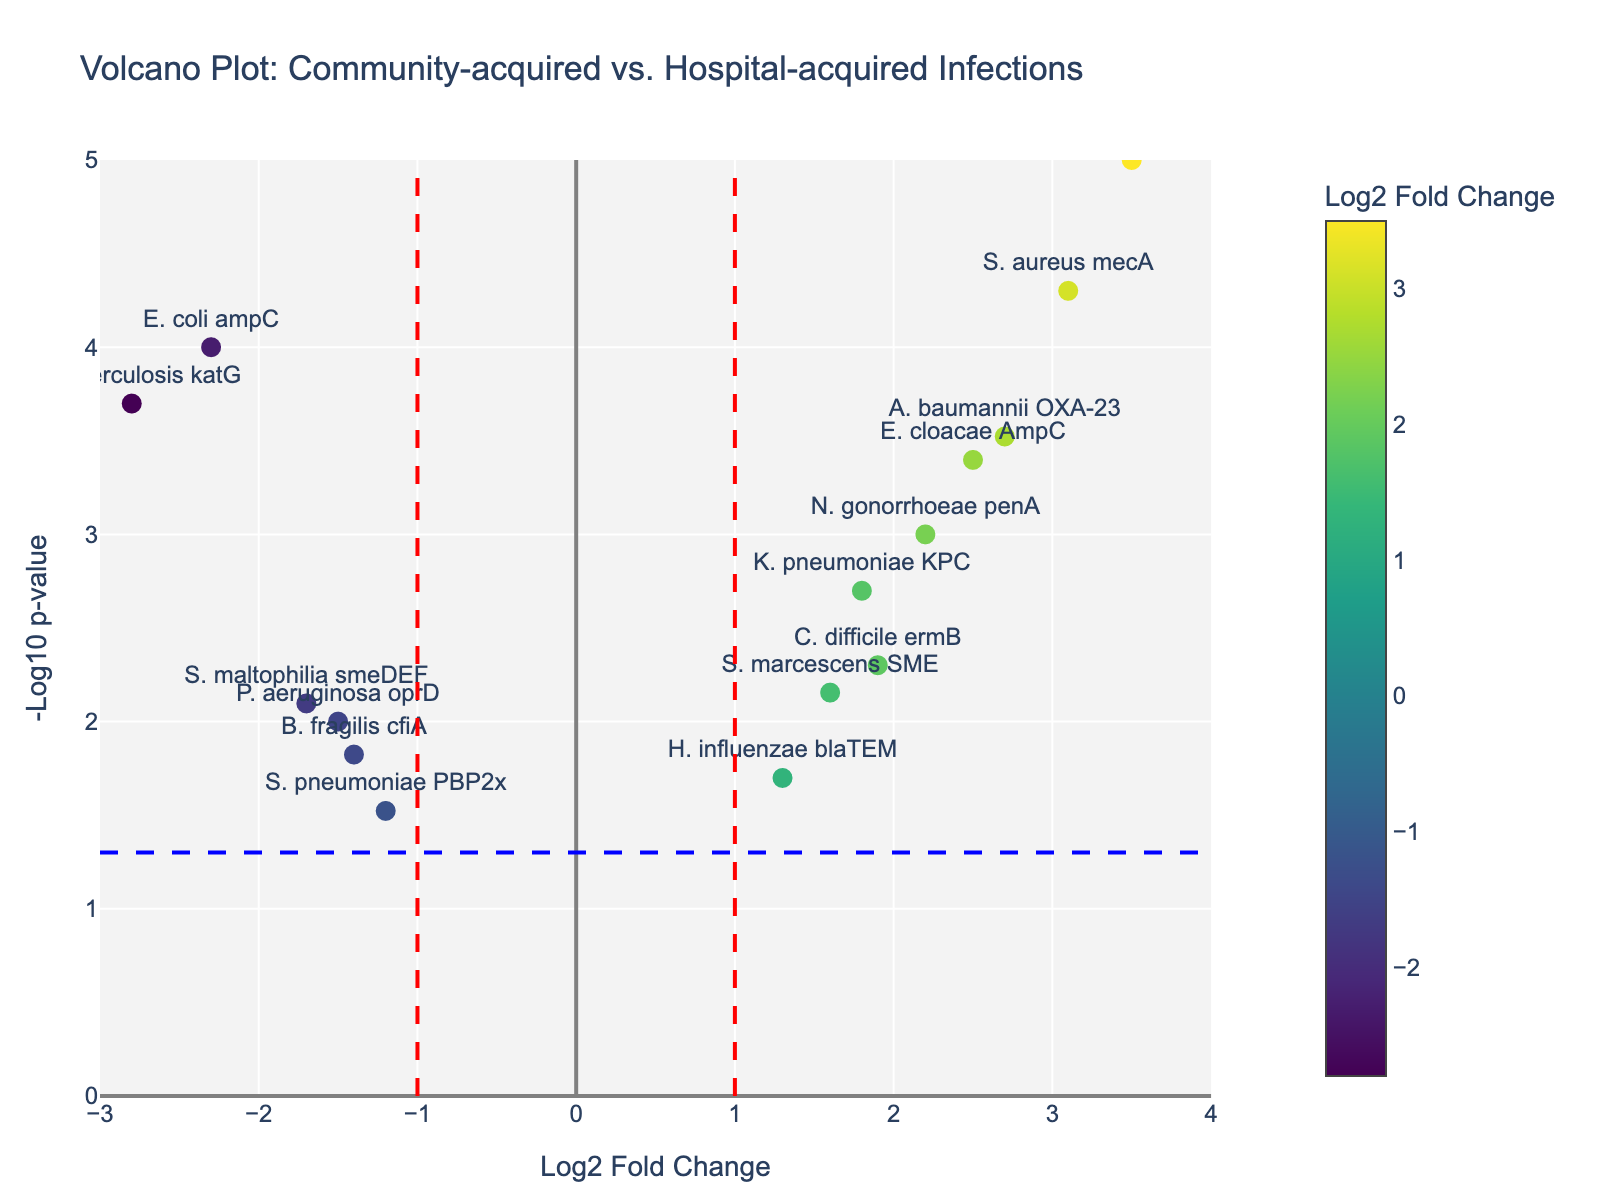What is the title of the volcano plot? The title is displayed at the top of the plot, which helps to contextualize the data being visualized. The title is "Volcano Plot: Community-acquired vs. Hospital-acquired Infections".
Answer: Volcano Plot: Community-acquired vs. Hospital-acquired Infections What does the horizontal blue dashed line represent? This line marks a specific statistical threshold, generally set at p-value = 0.05. It helps in identifying statistically significant data points. In this plot, it's at -log10(p-value) = 1.3, representing p-value = 0.05.
Answer: p-value = 0.05 threshold Which gene has the highest -log10(p-value)? Finding the highest point on the y-axis, we see that the gene with the highest -log10(p-value) is "E. faecium vanA". It is marked by its height along the y-axis.
Answer: E. faecium vanA What do the vertical red dashed lines on the plot signify? These lines are set at log2 fold change values of -1 and 1. They typically indicate boundaries for considering whether a gene is significantly downregulated (left of -1) or upregulated (right of +1).
Answer: log2 fold change of -1 and 1 Which gene shows the greatest increase in log2 fold change? The gene with the largest positive x-value (furthest to the right) indicates the greatest increase. This gene is "E. faecium vanA" with a log2 fold change of 3.5.
Answer: E. faecium vanA Which genes are statistically significant and downregulated? Statistically significant genes have p-values less than 0.05 (-log10(p-value) > 1.3) and downregulated genes have negative log2 fold change. The genes fitting these criteria are "E. coli ampC", "P. aeruginosa oprD", "M. tuberculosis katG", and "S. maltophilia smeDEF".
Answer: E. coli ampC, P. aeruginosa oprD, M. tuberculosis katG, S. maltophilia smeDEF Compare the log2 fold change of "S. aureus mecA" and "B. fragilis cfiA". Which one is higher? Evaluate the x-values for both points. "S. aureus mecA" has a log2 fold change of 3.1, while "B. fragilis cfiA" has a log2 fold change of -1.4. Thus, "S. aureus mecA" has a higher log2 fold change.
Answer: S. aureus mecA Which genes have a log2 fold change between -1 and 1? Look for genes where the x-value falls between -1 and 1. These include "S. pneumoniae PBP2x", "H. influenzae blaTEM", and "S. marcescens SME".
Answer: S. pneumoniae PBP2x, H. influenzae blaTEM, S. marcescens SME How many genes have a -log10(p-value) above 2? Count the number of data points above -log10(p-value) = 2. The genes are "E. faecium vanA", "S. aureus mecA", "E. coli ampC", and "M. tuberculosis katG". So, there are 4 genes.
Answer: 4 What color represents the highest log2 fold change values? The color scale (Viridis) indicates that points with the highest log2 fold change values are represented by the warmest, brightest colors (yellowish tones).
Answer: Yellowish tones 